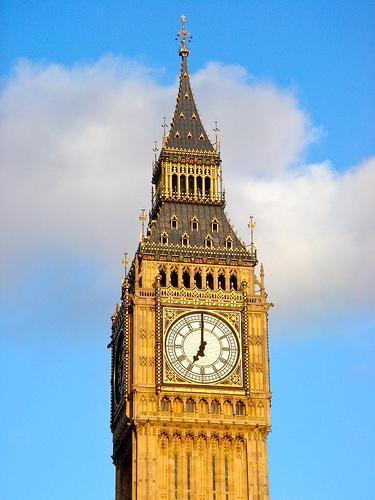How many clock faces can be seen?
Give a very brief answer. 2. 